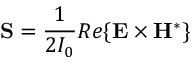Convert formula to latex. <formula><loc_0><loc_0><loc_500><loc_500>\mathbf S = \frac { 1 } { 2 I _ { 0 } } R e \{ \mathbf E \times \mathbf H ^ { * } \}</formula> 